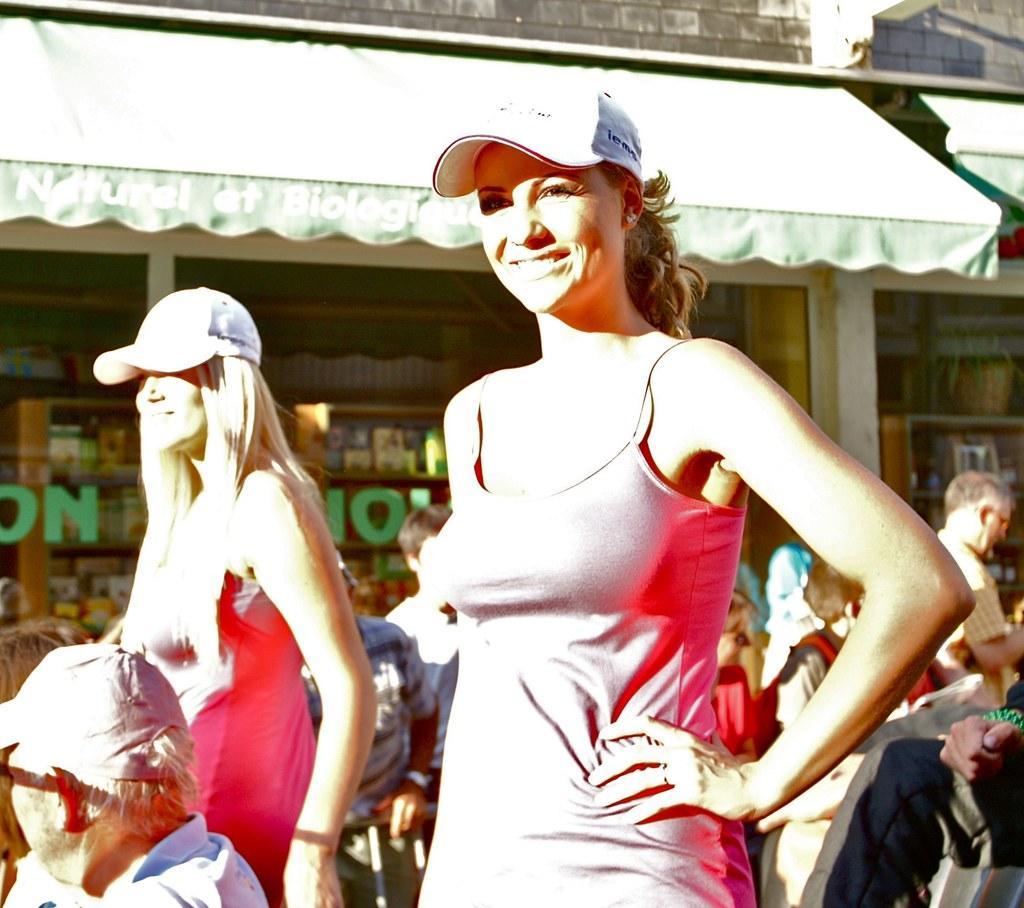In one or two sentences, can you explain what this image depicts? In this image in the front there are woman standing and smiling and in the background there are persons sitting and walking and there is a tent and there is a glass and behind the glass there are objects. On the glass there is some text written on it. Behind the tents there is a wall on the top. 